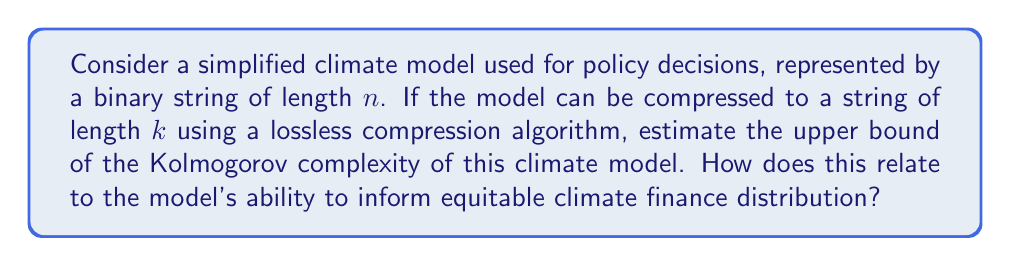Solve this math problem. To estimate the upper bound of the Kolmogorov complexity of the climate model, we need to consider the following steps:

1. Kolmogorov complexity is defined as the length of the shortest program that can produce the given string. In this case, our string represents the climate model.

2. The lossless compression of the model to a string of length $k$ provides an upper bound for the Kolmogorov complexity. This is because the decompression algorithm plus the compressed string can be considered a program that produces the original model.

3. Let's denote the length of the decompression algorithm as $c$. The total length of the program that can produce the original model is then $k + c$.

4. Therefore, the upper bound of the Kolmogorov complexity $K(x)$ for our climate model $x$ is:

   $$K(x) \leq k + c$$

5. The constant $c$ is independent of the input string (our climate model) and depends only on the chosen decompression algorithm.

6. The ratio of the compressed length to the original length provides insight into the model's complexity:

   $$\text{Compression ratio} = \frac{k}{n}$$

7. A lower compression ratio indicates a more complex model, as it contains more information that cannot be easily compressed.

8. In terms of climate finance distribution, a model with lower Kolmogorov complexity (i.e., more compressible) might be considered more transparent and easier to interpret. This could facilitate more equitable decision-making processes, as the model's predictions and assumptions would be more accessible to various stakeholders.

9. However, a more complex model (higher Kolmogorov complexity) might capture more nuanced climate patterns, potentially leading to more accurate predictions and fairer distribution of climate finance based on detailed regional differences.

10. The trade-off between model complexity and interpretability is crucial for ensuring equitable climate finance distribution, as it affects the transparency of decision-making processes and the accuracy of climate impact assessments.
Answer: The upper bound of the Kolmogorov complexity of the climate model is $K(x) \leq k + c$, where $k$ is the length of the compressed string and $c$ is the length of the decompression algorithm. This relates to equitable climate finance distribution by influencing the trade-off between model interpretability and accuracy, which affects the transparency and fairness of climate policy decisions. 